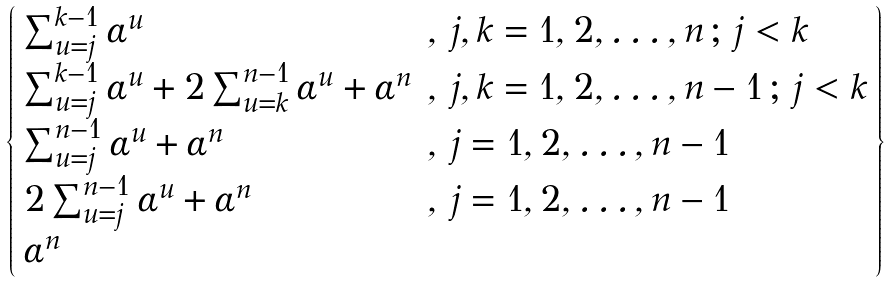<formula> <loc_0><loc_0><loc_500><loc_500>\left \{ \begin{array} { l l } \sum _ { u = j } ^ { k - 1 } \alpha ^ { u } & , \, j , k = 1 , 2 , \dots , n \, ; \, j < k \\ \sum _ { u = j } ^ { k - 1 } \alpha ^ { u } + 2 \sum _ { u = k } ^ { n - 1 } \alpha ^ { u } + \alpha ^ { n } & , \, j , k = 1 , 2 , \dots , n - 1 \, ; \, j < k \\ \sum _ { u = j } ^ { n - 1 } \alpha ^ { u } + \alpha ^ { n } & , \, j = 1 , 2 , \dots , n - 1 \\ 2 \sum _ { u = j } ^ { n - 1 } \alpha ^ { u } + \alpha ^ { n } & , \, j = 1 , 2 , \dots , n - 1 \\ \alpha ^ { n } & \end{array} \right \}</formula> 